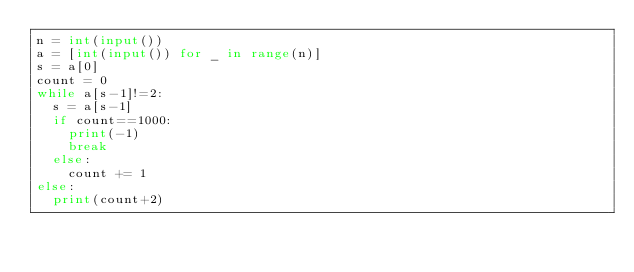<code> <loc_0><loc_0><loc_500><loc_500><_Python_>n = int(input())
a = [int(input()) for _ in range(n)]
s = a[0]
count = 0
while a[s-1]!=2:
  s = a[s-1]
  if count==1000:
    print(-1)
    break
  else:
    count += 1
else:
  print(count+2)</code> 